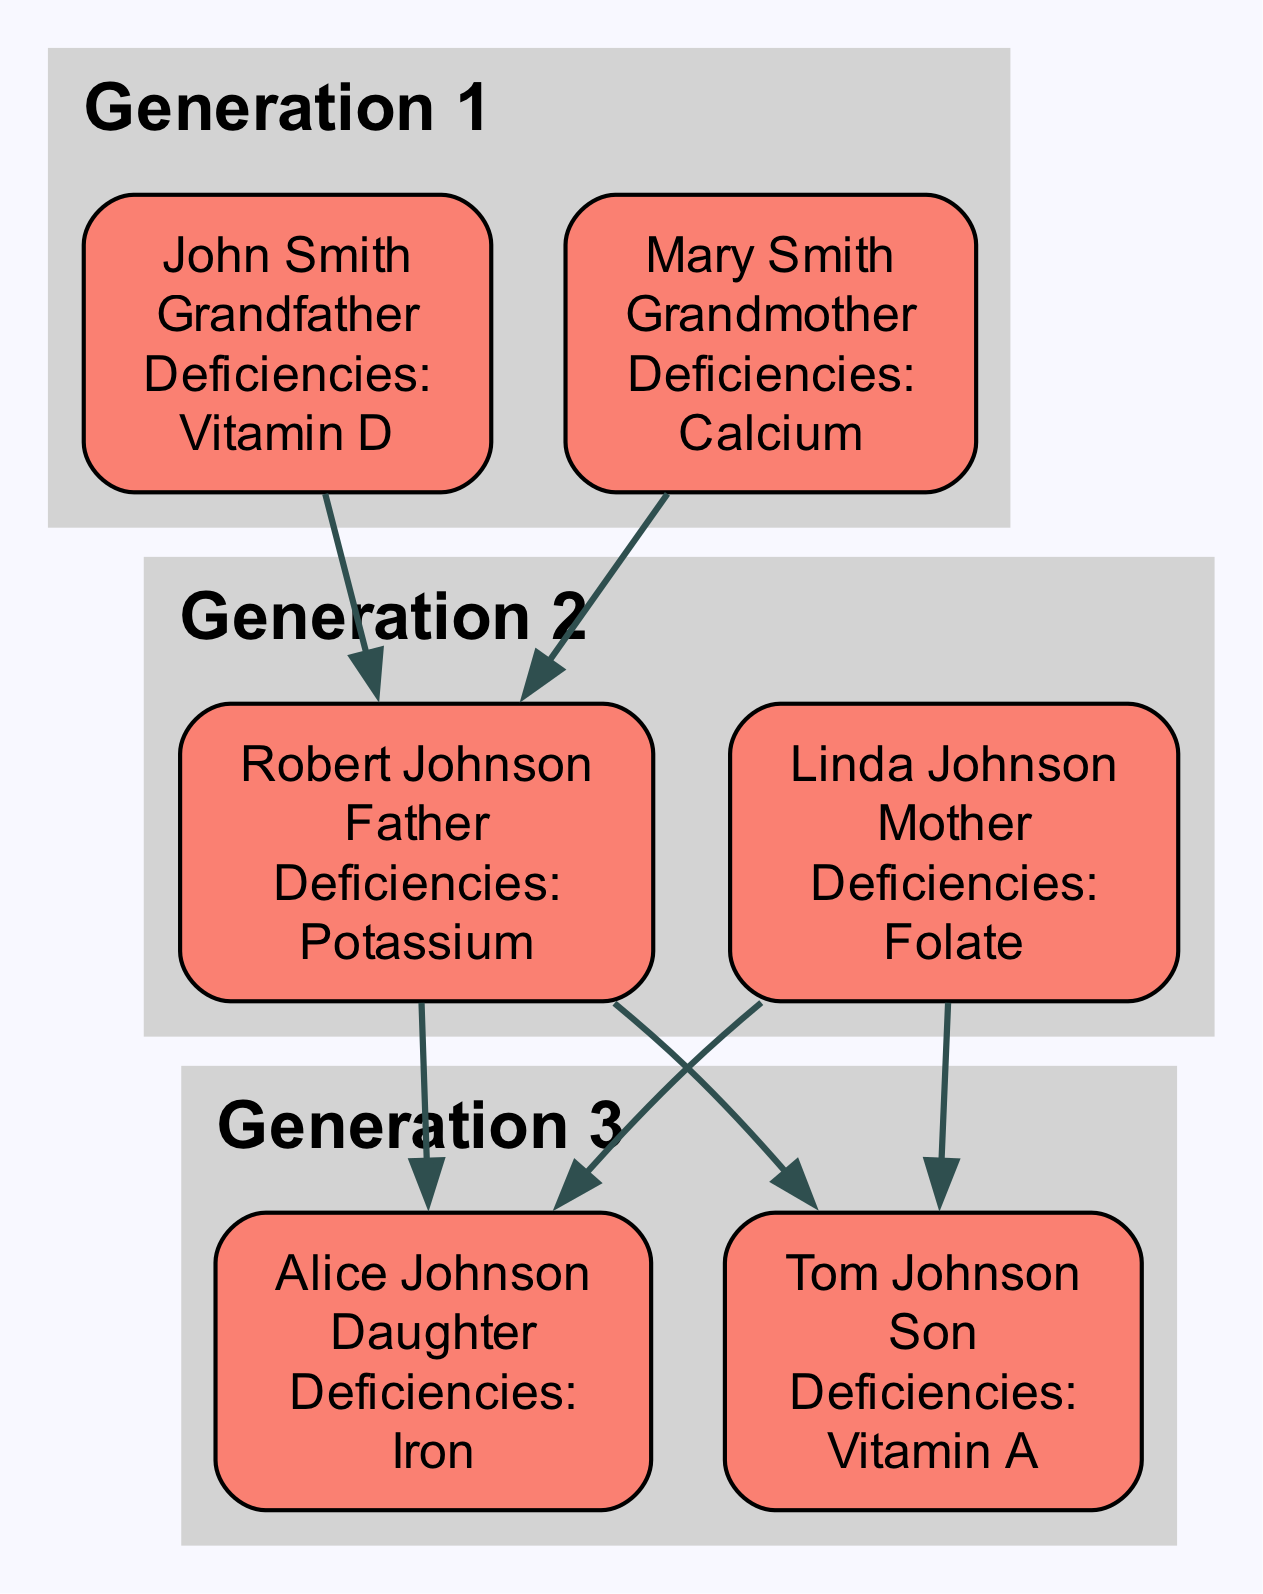What vitamin deficiency does John Smith have? The diagram shows 'Vitamin D' listed under John Smith's deficiencies, indicating that he has a deficiency in this vitamin.
Answer: Vitamin D How many family members have a deficiency in Iron? In the diagram, Alice Johnson has a listed deficiency in Iron. Therefore, the count of family members with an Iron deficiency is one.
Answer: 1 Which generation does Tom Johnson belong to? The diagram specifies that Tom Johnson is categorized as a member of Generation 3.
Answer: Generation 3 What is the relationship of Robert Johnson to Mary Smith? The diagram indicates that Robert Johnson is the son of Mary Smith, establishing the relationship as mother and son.
Answer: Son Which vitamin deficiency is common between Alice Johnson and John Smith? Looking at the diagram, Iron is a deficiency mentioned for Alice Johnson and is also listed for John Smith. Both have this deficiency, showing a connection between them.
Answer: Iron Who has a deficiency in Folate? The diagram clearly states that Linda Johnson has a deficiency in Folate, showing her biological relationship in the context of the family tree.
Answer: Linda Johnson How many deficiencies does Tom Johnson have? The diagram shows that Tom Johnson has a deficiency in Vitamin A, but not in any other vitamins, so he has one deficiency total.
Answer: 1 Which family members do not have any deficiencies? According to the diagram, both Mary Smith and Robert Johnson do not have any listed deficiencies, signifying that they are free from specific vitamin or mineral deficiencies.
Answer: Mary Smith, Robert Johnson What mineral deficiency does Robert Johnson have? The diagram indicates that Robert Johnson has a deficiency in Potassium, making it the mineral he is lacking.
Answer: Potassium 